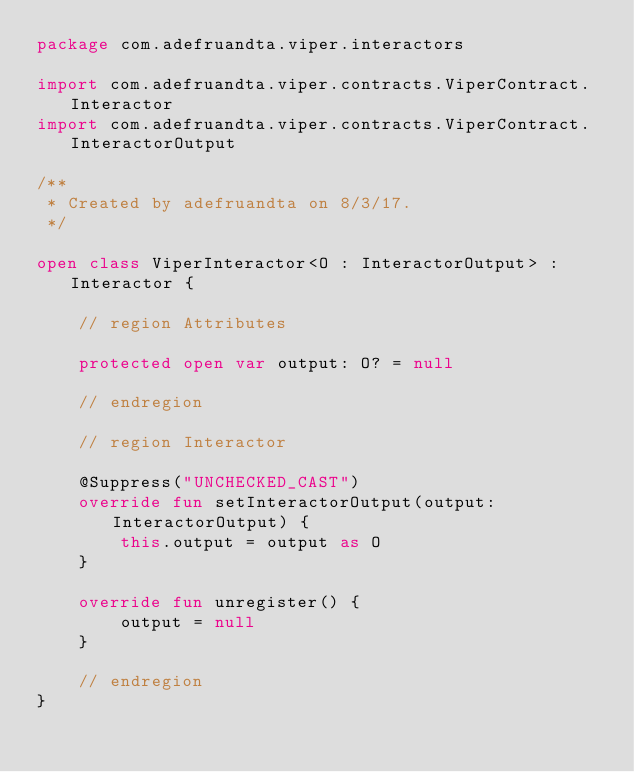Convert code to text. <code><loc_0><loc_0><loc_500><loc_500><_Kotlin_>package com.adefruandta.viper.interactors

import com.adefruandta.viper.contracts.ViperContract.Interactor
import com.adefruandta.viper.contracts.ViperContract.InteractorOutput

/**
 * Created by adefruandta on 8/3/17.
 */

open class ViperInteractor<O : InteractorOutput> : Interactor {

    // region Attributes

    protected open var output: O? = null

    // endregion

    // region Interactor

    @Suppress("UNCHECKED_CAST")
    override fun setInteractorOutput(output: InteractorOutput) {
        this.output = output as O
    }

    override fun unregister() {
        output = null
    }

    // endregion
}
</code> 